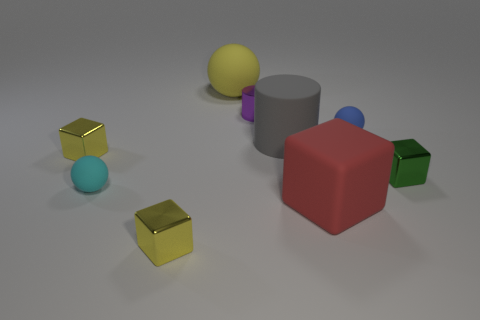Add 1 small yellow objects. How many objects exist? 10 Subtract all blocks. How many objects are left? 5 Add 3 small blue balls. How many small blue balls are left? 4 Add 2 small shiny cubes. How many small shiny cubes exist? 5 Subtract 1 green cubes. How many objects are left? 8 Subtract all gray matte cylinders. Subtract all small cyan objects. How many objects are left? 7 